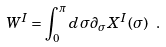<formula> <loc_0><loc_0><loc_500><loc_500>W ^ { I } = \int _ { 0 } ^ { \pi } d \sigma \partial _ { \sigma } X ^ { I } ( \sigma ) \ .</formula> 